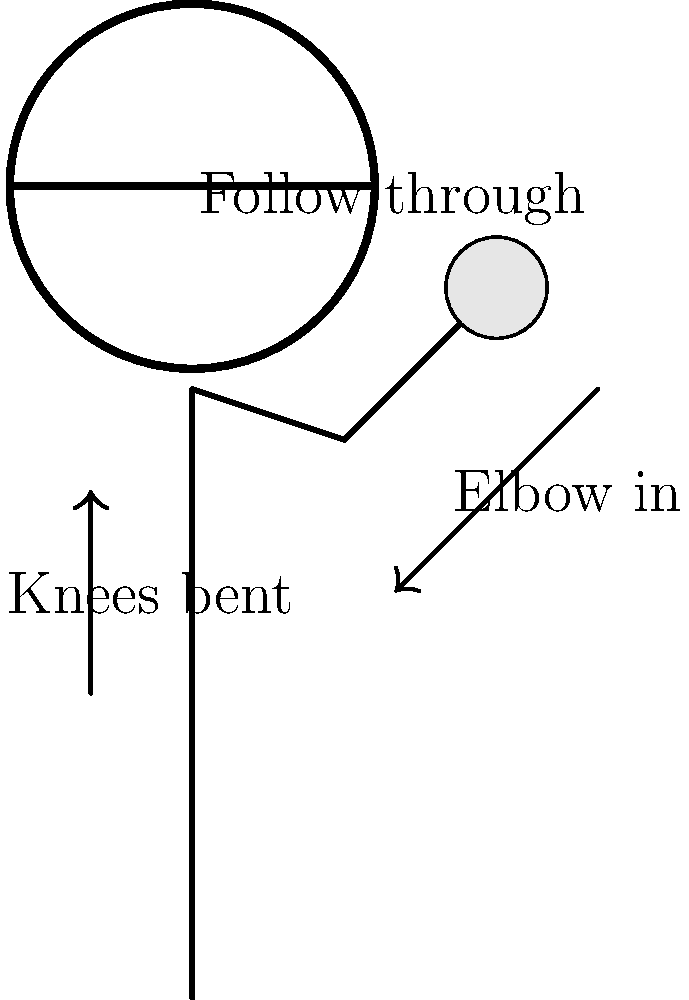In the diagram illustrating proper free throw form, which aspect of the shooting technique is not explicitly highlighted but is crucial for maintaining balance and generating power? Let's analyze the key components of proper free throw form as shown in the diagram:

1. Knee bend: The diagram shows bent knees, which is crucial for generating power.
2. Elbow position: The elbow is shown tucked in, which is important for shot accuracy.
3. Follow-through: The wrist position indicates a proper follow-through, essential for shot control.
4. Ball position: The ball is held high, near the shooter's forehead.

However, one crucial aspect not explicitly highlighted in the diagram is the positioning of the feet. In proper free throw form:

5. Feet positioning: The feet should be shoulder-width apart, with the dominant foot slightly ahead of the other. This stance provides a stable base and allows for proper weight transfer during the shot.

While the diagram focuses on upper body mechanics, the foundation of a good free throw lies in the lower body, starting with proper foot placement. This aspect is critical for maintaining balance throughout the shot and effectively transferring energy from the legs through the upper body.
Answer: Feet positioning 